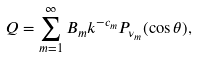<formula> <loc_0><loc_0><loc_500><loc_500>Q = \sum _ { m = 1 } ^ { \infty } B _ { m } k ^ { - c _ { m } } P _ { \nu _ { m } } ( \cos \theta ) ,</formula> 